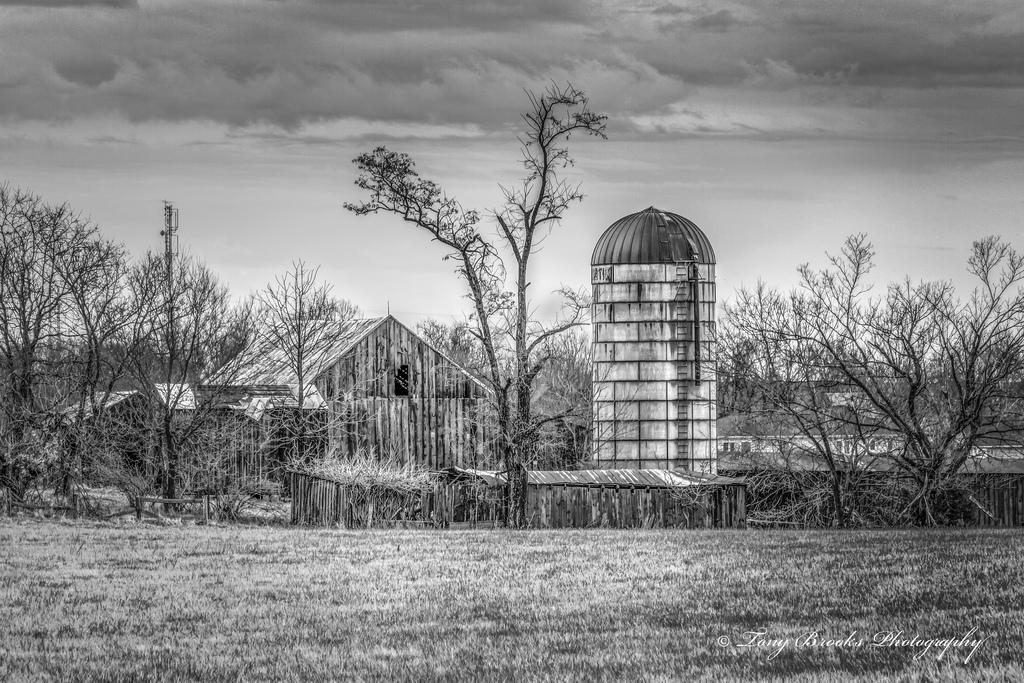What type of natural elements can be seen in the image? There are trees in the image. What type of man-made structures are present in the image? There are buildings in the image. What is visible at the top of the image? The sky is visible at the top of the image. What is the color scheme of the image? The image is in black and white. What idea does the stomach have about the trouble in the image? There is no stomach or idea present in the image; it features trees, buildings, and a black and white color scheme. 